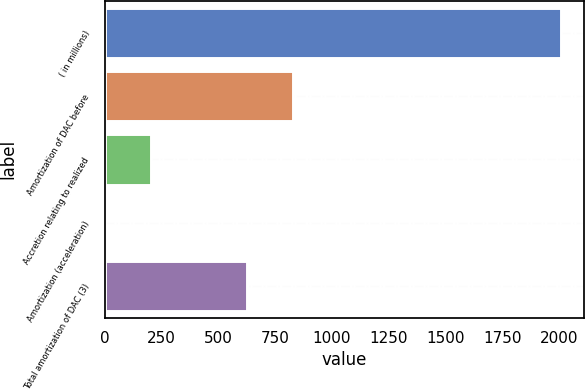<chart> <loc_0><loc_0><loc_500><loc_500><bar_chart><fcel>( in millions)<fcel>Amortization of DAC before<fcel>Accretion relating to realized<fcel>Amortization (acceleration)<fcel>Total amortization of DAC (3)<nl><fcel>2006<fcel>826.4<fcel>202.4<fcel>2<fcel>626<nl></chart> 